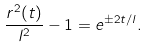Convert formula to latex. <formula><loc_0><loc_0><loc_500><loc_500>\frac { r ^ { 2 } ( t ) } { l ^ { 2 } } - 1 = e ^ { \pm 2 t / l } .</formula> 